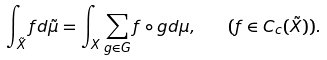<formula> <loc_0><loc_0><loc_500><loc_500>\int _ { \tilde { X } } f d \tilde { \mu } = \int _ { X } { \sum _ { g \in G } f \circ g } d \mu , \quad ( f \in C _ { c } ( \tilde { X } ) ) .</formula> 